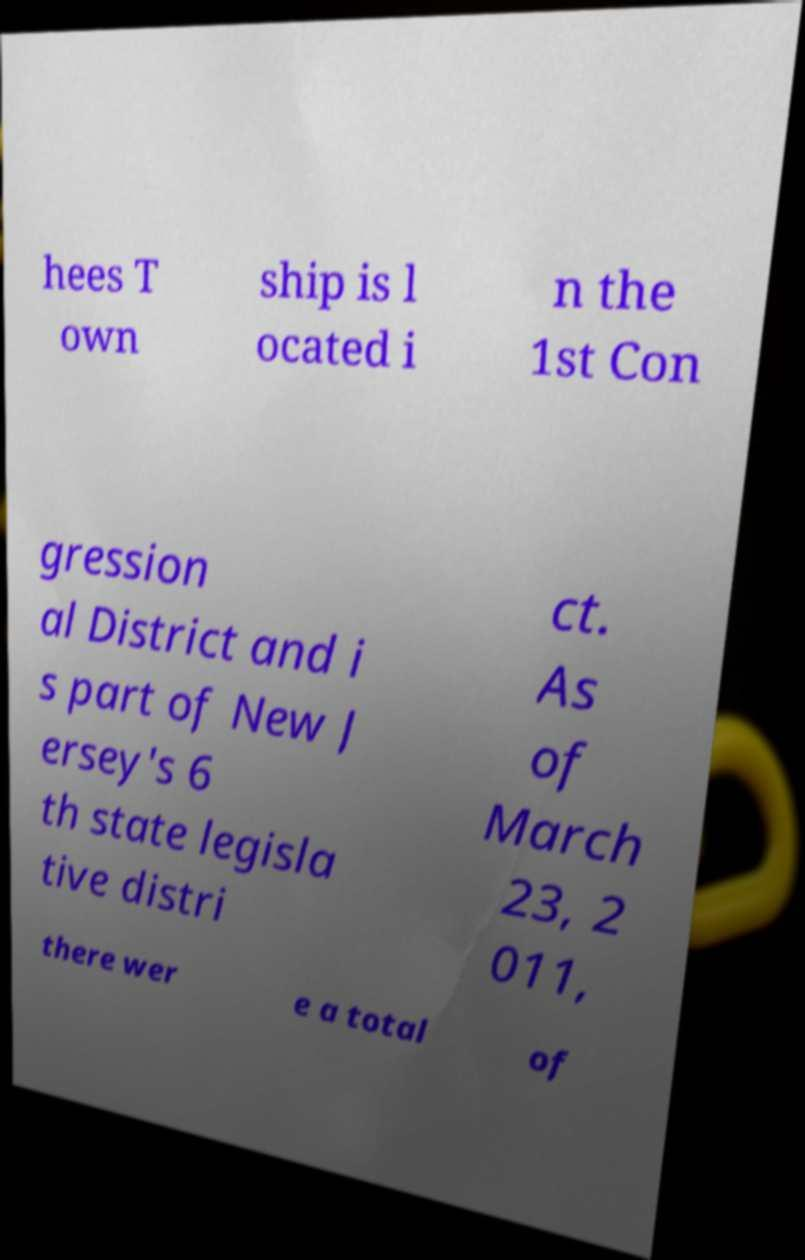Please identify and transcribe the text found in this image. hees T own ship is l ocated i n the 1st Con gression al District and i s part of New J ersey's 6 th state legisla tive distri ct. As of March 23, 2 011, there wer e a total of 